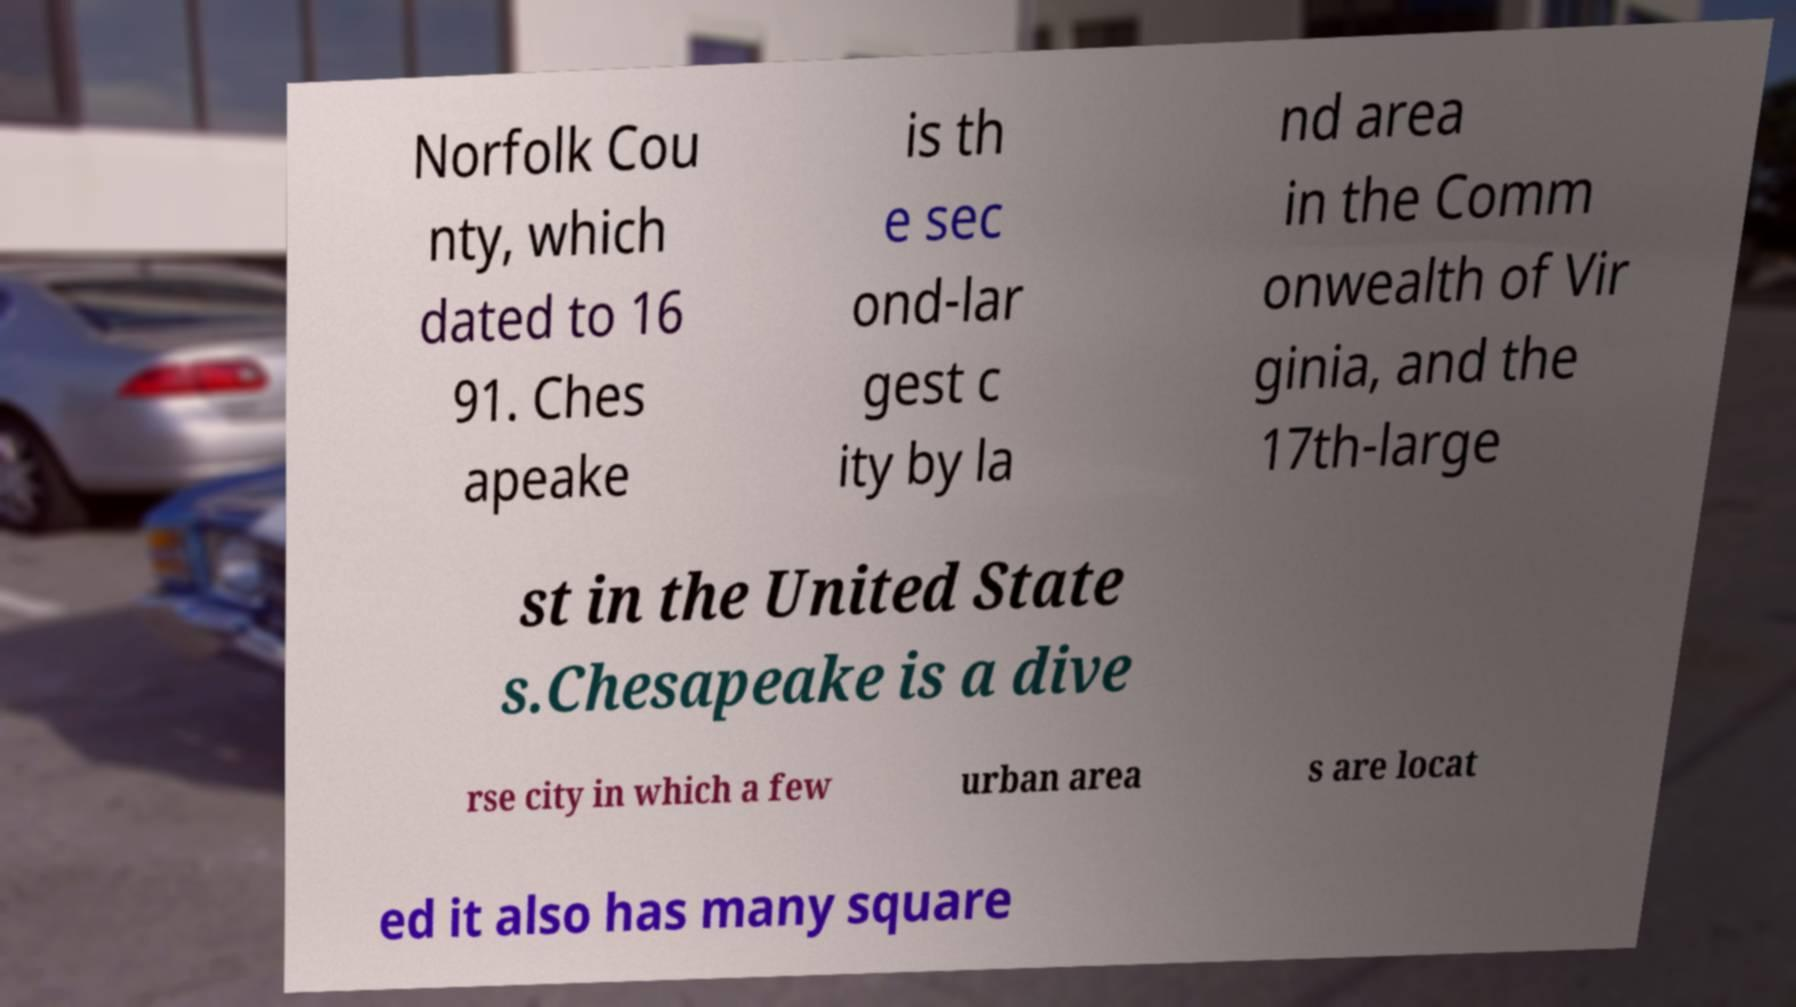Can you accurately transcribe the text from the provided image for me? Norfolk Cou nty, which dated to 16 91. Ches apeake is th e sec ond-lar gest c ity by la nd area in the Comm onwealth of Vir ginia, and the 17th-large st in the United State s.Chesapeake is a dive rse city in which a few urban area s are locat ed it also has many square 